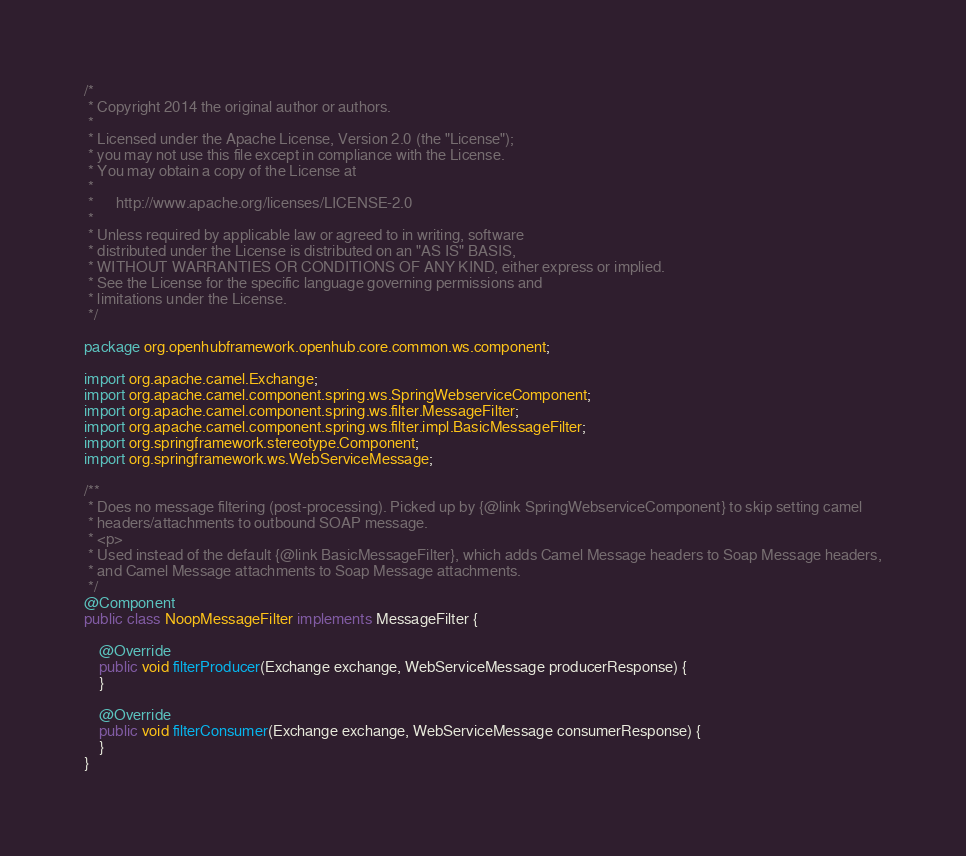<code> <loc_0><loc_0><loc_500><loc_500><_Java_>/*
 * Copyright 2014 the original author or authors.
 *
 * Licensed under the Apache License, Version 2.0 (the "License");
 * you may not use this file except in compliance with the License.
 * You may obtain a copy of the License at
 *
 *      http://www.apache.org/licenses/LICENSE-2.0
 *
 * Unless required by applicable law or agreed to in writing, software
 * distributed under the License is distributed on an "AS IS" BASIS,
 * WITHOUT WARRANTIES OR CONDITIONS OF ANY KIND, either express or implied.
 * See the License for the specific language governing permissions and
 * limitations under the License.
 */

package org.openhubframework.openhub.core.common.ws.component;

import org.apache.camel.Exchange;
import org.apache.camel.component.spring.ws.SpringWebserviceComponent;
import org.apache.camel.component.spring.ws.filter.MessageFilter;
import org.apache.camel.component.spring.ws.filter.impl.BasicMessageFilter;
import org.springframework.stereotype.Component;
import org.springframework.ws.WebServiceMessage;

/**
 * Does no message filtering (post-processing). Picked up by {@link SpringWebserviceComponent} to skip setting camel
 * headers/attachments to outbound SOAP message.
 * <p>
 * Used instead of the default {@link BasicMessageFilter}, which adds Camel Message headers to Soap Message headers,
 * and Camel Message attachments to Soap Message attachments.
 */
@Component
public class NoopMessageFilter implements MessageFilter {

    @Override
    public void filterProducer(Exchange exchange, WebServiceMessage producerResponse) {
    }

    @Override
    public void filterConsumer(Exchange exchange, WebServiceMessage consumerResponse) {
    }
}
</code> 